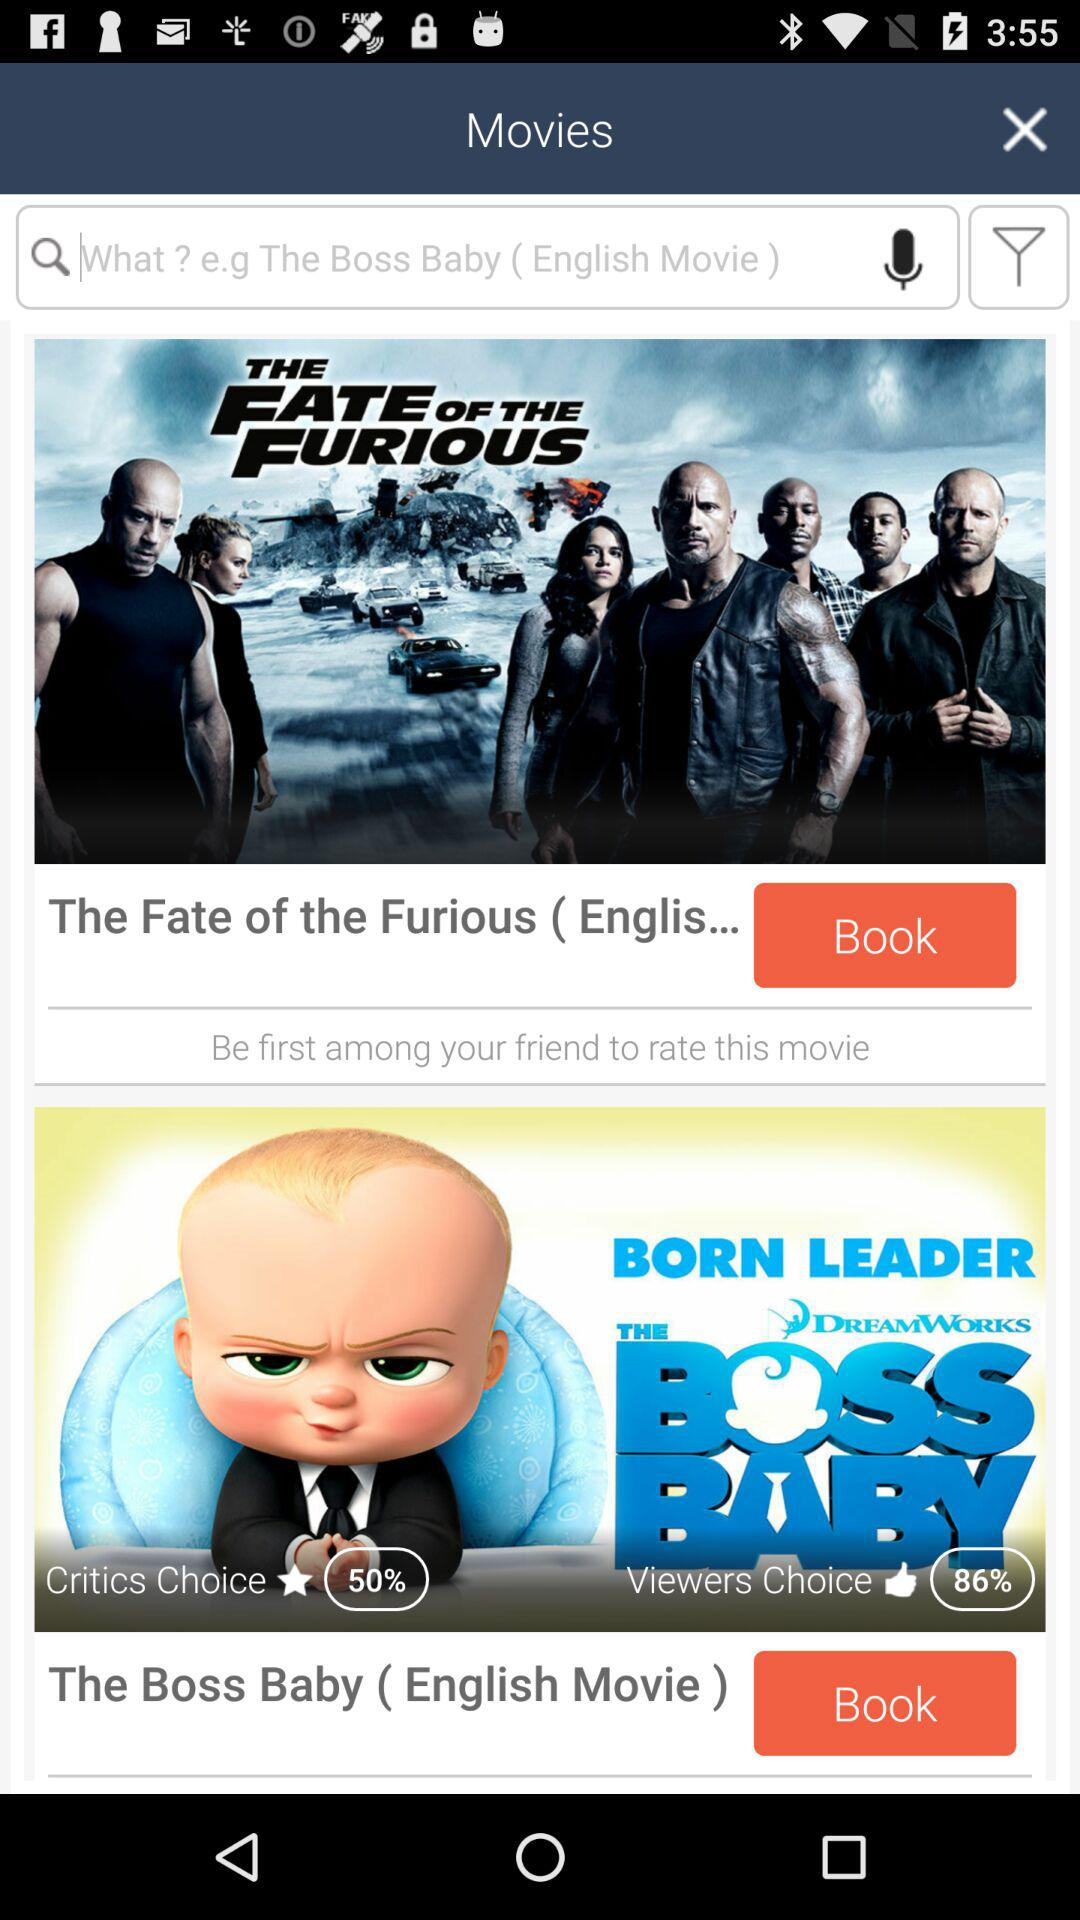What is the percentage mentioned for "Critics Choice"? The percentage mentioned for "Critics Choice" is 50. 